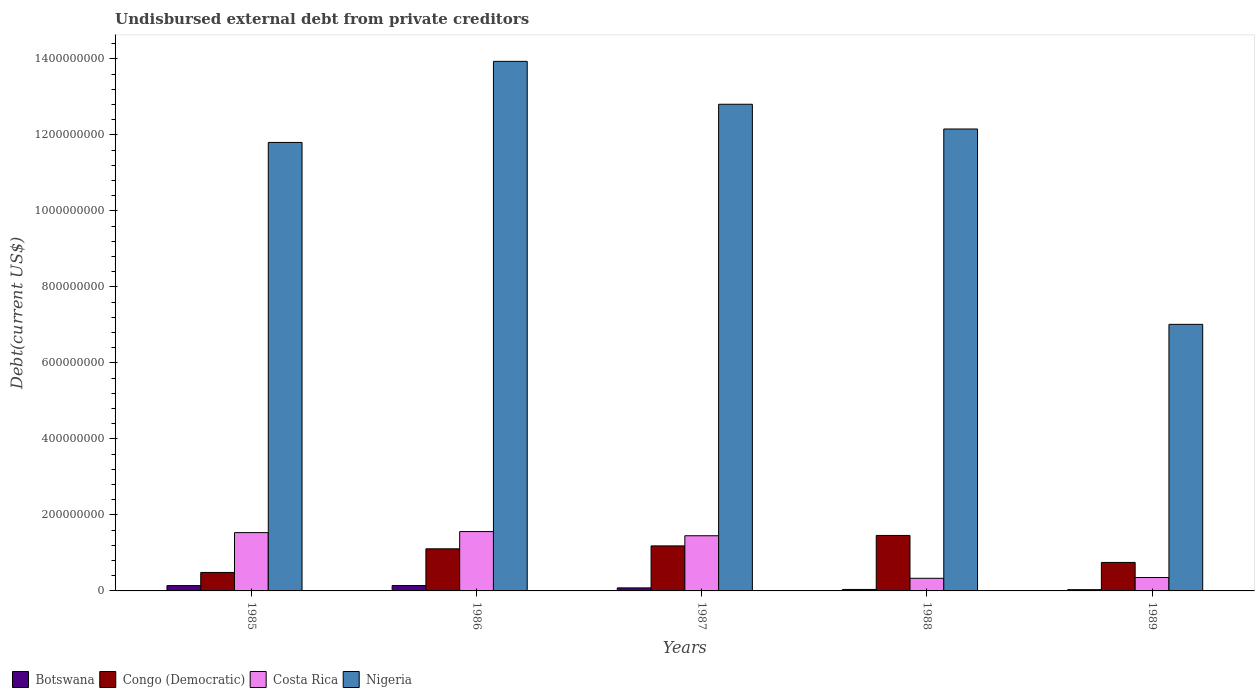How many bars are there on the 1st tick from the left?
Your answer should be very brief. 4. What is the total debt in Congo (Democratic) in 1988?
Provide a short and direct response. 1.46e+08. Across all years, what is the maximum total debt in Costa Rica?
Provide a short and direct response. 1.56e+08. Across all years, what is the minimum total debt in Nigeria?
Your answer should be compact. 7.01e+08. In which year was the total debt in Congo (Democratic) maximum?
Offer a very short reply. 1988. What is the total total debt in Costa Rica in the graph?
Ensure brevity in your answer.  5.23e+08. What is the difference between the total debt in Botswana in 1985 and that in 1987?
Make the answer very short. 6.06e+06. What is the difference between the total debt in Costa Rica in 1988 and the total debt in Botswana in 1986?
Offer a terse response. 1.90e+07. What is the average total debt in Botswana per year?
Offer a very short reply. 8.68e+06. In the year 1985, what is the difference between the total debt in Nigeria and total debt in Costa Rica?
Provide a short and direct response. 1.03e+09. In how many years, is the total debt in Congo (Democratic) greater than 800000000 US$?
Keep it short and to the point. 0. What is the ratio of the total debt in Botswana in 1985 to that in 1987?
Your answer should be compact. 1.76. Is the difference between the total debt in Nigeria in 1988 and 1989 greater than the difference between the total debt in Costa Rica in 1988 and 1989?
Provide a short and direct response. Yes. What is the difference between the highest and the second highest total debt in Costa Rica?
Ensure brevity in your answer.  2.75e+06. What is the difference between the highest and the lowest total debt in Botswana?
Provide a succinct answer. 1.09e+07. Is it the case that in every year, the sum of the total debt in Costa Rica and total debt in Congo (Democratic) is greater than the sum of total debt in Nigeria and total debt in Botswana?
Provide a succinct answer. Yes. What does the 2nd bar from the left in 1988 represents?
Provide a short and direct response. Congo (Democratic). What does the 4th bar from the right in 1986 represents?
Your answer should be compact. Botswana. Is it the case that in every year, the sum of the total debt in Botswana and total debt in Congo (Democratic) is greater than the total debt in Costa Rica?
Your answer should be compact. No. Are all the bars in the graph horizontal?
Your answer should be compact. No. How many years are there in the graph?
Provide a succinct answer. 5. What is the difference between two consecutive major ticks on the Y-axis?
Your response must be concise. 2.00e+08. Are the values on the major ticks of Y-axis written in scientific E-notation?
Keep it short and to the point. No. Where does the legend appear in the graph?
Your response must be concise. Bottom left. How many legend labels are there?
Your answer should be very brief. 4. How are the legend labels stacked?
Your answer should be compact. Horizontal. What is the title of the graph?
Provide a short and direct response. Undisbursed external debt from private creditors. Does "Congo (Democratic)" appear as one of the legend labels in the graph?
Provide a short and direct response. Yes. What is the label or title of the X-axis?
Give a very brief answer. Years. What is the label or title of the Y-axis?
Give a very brief answer. Debt(current US$). What is the Debt(current US$) in Botswana in 1985?
Ensure brevity in your answer.  1.41e+07. What is the Debt(current US$) in Congo (Democratic) in 1985?
Offer a terse response. 4.86e+07. What is the Debt(current US$) in Costa Rica in 1985?
Offer a terse response. 1.53e+08. What is the Debt(current US$) in Nigeria in 1985?
Offer a terse response. 1.18e+09. What is the Debt(current US$) in Botswana in 1986?
Offer a very short reply. 1.42e+07. What is the Debt(current US$) of Congo (Democratic) in 1986?
Your answer should be very brief. 1.11e+08. What is the Debt(current US$) in Costa Rica in 1986?
Ensure brevity in your answer.  1.56e+08. What is the Debt(current US$) of Nigeria in 1986?
Make the answer very short. 1.39e+09. What is the Debt(current US$) in Botswana in 1987?
Give a very brief answer. 7.99e+06. What is the Debt(current US$) in Congo (Democratic) in 1987?
Ensure brevity in your answer.  1.18e+08. What is the Debt(current US$) of Costa Rica in 1987?
Give a very brief answer. 1.45e+08. What is the Debt(current US$) in Nigeria in 1987?
Provide a short and direct response. 1.28e+09. What is the Debt(current US$) of Botswana in 1988?
Offer a terse response. 3.90e+06. What is the Debt(current US$) of Congo (Democratic) in 1988?
Provide a succinct answer. 1.46e+08. What is the Debt(current US$) in Costa Rica in 1988?
Provide a succinct answer. 3.32e+07. What is the Debt(current US$) of Nigeria in 1988?
Ensure brevity in your answer.  1.22e+09. What is the Debt(current US$) of Botswana in 1989?
Keep it short and to the point. 3.28e+06. What is the Debt(current US$) of Congo (Democratic) in 1989?
Ensure brevity in your answer.  7.50e+07. What is the Debt(current US$) in Costa Rica in 1989?
Offer a very short reply. 3.53e+07. What is the Debt(current US$) in Nigeria in 1989?
Provide a succinct answer. 7.01e+08. Across all years, what is the maximum Debt(current US$) of Botswana?
Ensure brevity in your answer.  1.42e+07. Across all years, what is the maximum Debt(current US$) of Congo (Democratic)?
Offer a terse response. 1.46e+08. Across all years, what is the maximum Debt(current US$) of Costa Rica?
Offer a very short reply. 1.56e+08. Across all years, what is the maximum Debt(current US$) in Nigeria?
Keep it short and to the point. 1.39e+09. Across all years, what is the minimum Debt(current US$) in Botswana?
Your response must be concise. 3.28e+06. Across all years, what is the minimum Debt(current US$) of Congo (Democratic)?
Provide a short and direct response. 4.86e+07. Across all years, what is the minimum Debt(current US$) in Costa Rica?
Make the answer very short. 3.32e+07. Across all years, what is the minimum Debt(current US$) in Nigeria?
Keep it short and to the point. 7.01e+08. What is the total Debt(current US$) of Botswana in the graph?
Provide a succinct answer. 4.34e+07. What is the total Debt(current US$) in Congo (Democratic) in the graph?
Ensure brevity in your answer.  4.99e+08. What is the total Debt(current US$) in Costa Rica in the graph?
Make the answer very short. 5.23e+08. What is the total Debt(current US$) of Nigeria in the graph?
Your answer should be compact. 5.77e+09. What is the difference between the Debt(current US$) of Botswana in 1985 and that in 1986?
Give a very brief answer. -1.43e+05. What is the difference between the Debt(current US$) in Congo (Democratic) in 1985 and that in 1986?
Make the answer very short. -6.22e+07. What is the difference between the Debt(current US$) of Costa Rica in 1985 and that in 1986?
Provide a short and direct response. -2.75e+06. What is the difference between the Debt(current US$) of Nigeria in 1985 and that in 1986?
Provide a short and direct response. -2.13e+08. What is the difference between the Debt(current US$) of Botswana in 1985 and that in 1987?
Your answer should be very brief. 6.06e+06. What is the difference between the Debt(current US$) in Congo (Democratic) in 1985 and that in 1987?
Give a very brief answer. -6.99e+07. What is the difference between the Debt(current US$) of Costa Rica in 1985 and that in 1987?
Provide a succinct answer. 8.21e+06. What is the difference between the Debt(current US$) of Nigeria in 1985 and that in 1987?
Offer a very short reply. -1.00e+08. What is the difference between the Debt(current US$) of Botswana in 1985 and that in 1988?
Provide a succinct answer. 1.02e+07. What is the difference between the Debt(current US$) in Congo (Democratic) in 1985 and that in 1988?
Your response must be concise. -9.73e+07. What is the difference between the Debt(current US$) in Costa Rica in 1985 and that in 1988?
Offer a very short reply. 1.20e+08. What is the difference between the Debt(current US$) of Nigeria in 1985 and that in 1988?
Ensure brevity in your answer.  -3.53e+07. What is the difference between the Debt(current US$) in Botswana in 1985 and that in 1989?
Give a very brief answer. 1.08e+07. What is the difference between the Debt(current US$) in Congo (Democratic) in 1985 and that in 1989?
Provide a succinct answer. -2.64e+07. What is the difference between the Debt(current US$) in Costa Rica in 1985 and that in 1989?
Keep it short and to the point. 1.18e+08. What is the difference between the Debt(current US$) in Nigeria in 1985 and that in 1989?
Give a very brief answer. 4.79e+08. What is the difference between the Debt(current US$) of Botswana in 1986 and that in 1987?
Your response must be concise. 6.21e+06. What is the difference between the Debt(current US$) in Congo (Democratic) in 1986 and that in 1987?
Make the answer very short. -7.70e+06. What is the difference between the Debt(current US$) of Costa Rica in 1986 and that in 1987?
Your answer should be very brief. 1.10e+07. What is the difference between the Debt(current US$) in Nigeria in 1986 and that in 1987?
Keep it short and to the point. 1.13e+08. What is the difference between the Debt(current US$) of Botswana in 1986 and that in 1988?
Provide a succinct answer. 1.03e+07. What is the difference between the Debt(current US$) in Congo (Democratic) in 1986 and that in 1988?
Make the answer very short. -3.52e+07. What is the difference between the Debt(current US$) in Costa Rica in 1986 and that in 1988?
Offer a very short reply. 1.23e+08. What is the difference between the Debt(current US$) of Nigeria in 1986 and that in 1988?
Your answer should be very brief. 1.78e+08. What is the difference between the Debt(current US$) of Botswana in 1986 and that in 1989?
Provide a short and direct response. 1.09e+07. What is the difference between the Debt(current US$) of Congo (Democratic) in 1986 and that in 1989?
Offer a terse response. 3.58e+07. What is the difference between the Debt(current US$) of Costa Rica in 1986 and that in 1989?
Your response must be concise. 1.21e+08. What is the difference between the Debt(current US$) of Nigeria in 1986 and that in 1989?
Ensure brevity in your answer.  6.92e+08. What is the difference between the Debt(current US$) of Botswana in 1987 and that in 1988?
Provide a short and direct response. 4.09e+06. What is the difference between the Debt(current US$) of Congo (Democratic) in 1987 and that in 1988?
Offer a very short reply. -2.75e+07. What is the difference between the Debt(current US$) in Costa Rica in 1987 and that in 1988?
Offer a very short reply. 1.12e+08. What is the difference between the Debt(current US$) of Nigeria in 1987 and that in 1988?
Your answer should be very brief. 6.51e+07. What is the difference between the Debt(current US$) in Botswana in 1987 and that in 1989?
Make the answer very short. 4.70e+06. What is the difference between the Debt(current US$) of Congo (Democratic) in 1987 and that in 1989?
Offer a very short reply. 4.35e+07. What is the difference between the Debt(current US$) of Costa Rica in 1987 and that in 1989?
Offer a very short reply. 1.10e+08. What is the difference between the Debt(current US$) in Nigeria in 1987 and that in 1989?
Ensure brevity in your answer.  5.79e+08. What is the difference between the Debt(current US$) in Botswana in 1988 and that in 1989?
Offer a very short reply. 6.15e+05. What is the difference between the Debt(current US$) in Congo (Democratic) in 1988 and that in 1989?
Offer a terse response. 7.10e+07. What is the difference between the Debt(current US$) of Costa Rica in 1988 and that in 1989?
Your response must be concise. -2.06e+06. What is the difference between the Debt(current US$) in Nigeria in 1988 and that in 1989?
Your answer should be compact. 5.14e+08. What is the difference between the Debt(current US$) of Botswana in 1985 and the Debt(current US$) of Congo (Democratic) in 1986?
Your answer should be very brief. -9.67e+07. What is the difference between the Debt(current US$) in Botswana in 1985 and the Debt(current US$) in Costa Rica in 1986?
Provide a succinct answer. -1.42e+08. What is the difference between the Debt(current US$) in Botswana in 1985 and the Debt(current US$) in Nigeria in 1986?
Your answer should be compact. -1.38e+09. What is the difference between the Debt(current US$) of Congo (Democratic) in 1985 and the Debt(current US$) of Costa Rica in 1986?
Your answer should be compact. -1.08e+08. What is the difference between the Debt(current US$) of Congo (Democratic) in 1985 and the Debt(current US$) of Nigeria in 1986?
Offer a terse response. -1.34e+09. What is the difference between the Debt(current US$) of Costa Rica in 1985 and the Debt(current US$) of Nigeria in 1986?
Your response must be concise. -1.24e+09. What is the difference between the Debt(current US$) in Botswana in 1985 and the Debt(current US$) in Congo (Democratic) in 1987?
Provide a succinct answer. -1.04e+08. What is the difference between the Debt(current US$) of Botswana in 1985 and the Debt(current US$) of Costa Rica in 1987?
Offer a terse response. -1.31e+08. What is the difference between the Debt(current US$) in Botswana in 1985 and the Debt(current US$) in Nigeria in 1987?
Your answer should be compact. -1.27e+09. What is the difference between the Debt(current US$) of Congo (Democratic) in 1985 and the Debt(current US$) of Costa Rica in 1987?
Keep it short and to the point. -9.66e+07. What is the difference between the Debt(current US$) in Congo (Democratic) in 1985 and the Debt(current US$) in Nigeria in 1987?
Ensure brevity in your answer.  -1.23e+09. What is the difference between the Debt(current US$) of Costa Rica in 1985 and the Debt(current US$) of Nigeria in 1987?
Offer a terse response. -1.13e+09. What is the difference between the Debt(current US$) in Botswana in 1985 and the Debt(current US$) in Congo (Democratic) in 1988?
Your response must be concise. -1.32e+08. What is the difference between the Debt(current US$) of Botswana in 1985 and the Debt(current US$) of Costa Rica in 1988?
Your response must be concise. -1.92e+07. What is the difference between the Debt(current US$) of Botswana in 1985 and the Debt(current US$) of Nigeria in 1988?
Give a very brief answer. -1.20e+09. What is the difference between the Debt(current US$) in Congo (Democratic) in 1985 and the Debt(current US$) in Costa Rica in 1988?
Offer a very short reply. 1.54e+07. What is the difference between the Debt(current US$) in Congo (Democratic) in 1985 and the Debt(current US$) in Nigeria in 1988?
Ensure brevity in your answer.  -1.17e+09. What is the difference between the Debt(current US$) of Costa Rica in 1985 and the Debt(current US$) of Nigeria in 1988?
Provide a succinct answer. -1.06e+09. What is the difference between the Debt(current US$) in Botswana in 1985 and the Debt(current US$) in Congo (Democratic) in 1989?
Offer a terse response. -6.09e+07. What is the difference between the Debt(current US$) of Botswana in 1985 and the Debt(current US$) of Costa Rica in 1989?
Provide a short and direct response. -2.12e+07. What is the difference between the Debt(current US$) of Botswana in 1985 and the Debt(current US$) of Nigeria in 1989?
Give a very brief answer. -6.87e+08. What is the difference between the Debt(current US$) of Congo (Democratic) in 1985 and the Debt(current US$) of Costa Rica in 1989?
Give a very brief answer. 1.33e+07. What is the difference between the Debt(current US$) in Congo (Democratic) in 1985 and the Debt(current US$) in Nigeria in 1989?
Provide a short and direct response. -6.53e+08. What is the difference between the Debt(current US$) in Costa Rica in 1985 and the Debt(current US$) in Nigeria in 1989?
Give a very brief answer. -5.48e+08. What is the difference between the Debt(current US$) in Botswana in 1986 and the Debt(current US$) in Congo (Democratic) in 1987?
Your response must be concise. -1.04e+08. What is the difference between the Debt(current US$) of Botswana in 1986 and the Debt(current US$) of Costa Rica in 1987?
Ensure brevity in your answer.  -1.31e+08. What is the difference between the Debt(current US$) of Botswana in 1986 and the Debt(current US$) of Nigeria in 1987?
Make the answer very short. -1.27e+09. What is the difference between the Debt(current US$) of Congo (Democratic) in 1986 and the Debt(current US$) of Costa Rica in 1987?
Offer a terse response. -3.44e+07. What is the difference between the Debt(current US$) of Congo (Democratic) in 1986 and the Debt(current US$) of Nigeria in 1987?
Make the answer very short. -1.17e+09. What is the difference between the Debt(current US$) in Costa Rica in 1986 and the Debt(current US$) in Nigeria in 1987?
Offer a terse response. -1.12e+09. What is the difference between the Debt(current US$) in Botswana in 1986 and the Debt(current US$) in Congo (Democratic) in 1988?
Provide a succinct answer. -1.32e+08. What is the difference between the Debt(current US$) in Botswana in 1986 and the Debt(current US$) in Costa Rica in 1988?
Ensure brevity in your answer.  -1.90e+07. What is the difference between the Debt(current US$) of Botswana in 1986 and the Debt(current US$) of Nigeria in 1988?
Offer a very short reply. -1.20e+09. What is the difference between the Debt(current US$) of Congo (Democratic) in 1986 and the Debt(current US$) of Costa Rica in 1988?
Your answer should be compact. 7.76e+07. What is the difference between the Debt(current US$) in Congo (Democratic) in 1986 and the Debt(current US$) in Nigeria in 1988?
Keep it short and to the point. -1.10e+09. What is the difference between the Debt(current US$) in Costa Rica in 1986 and the Debt(current US$) in Nigeria in 1988?
Your response must be concise. -1.06e+09. What is the difference between the Debt(current US$) in Botswana in 1986 and the Debt(current US$) in Congo (Democratic) in 1989?
Offer a very short reply. -6.08e+07. What is the difference between the Debt(current US$) of Botswana in 1986 and the Debt(current US$) of Costa Rica in 1989?
Your answer should be compact. -2.11e+07. What is the difference between the Debt(current US$) of Botswana in 1986 and the Debt(current US$) of Nigeria in 1989?
Your answer should be very brief. -6.87e+08. What is the difference between the Debt(current US$) in Congo (Democratic) in 1986 and the Debt(current US$) in Costa Rica in 1989?
Provide a short and direct response. 7.55e+07. What is the difference between the Debt(current US$) of Congo (Democratic) in 1986 and the Debt(current US$) of Nigeria in 1989?
Your response must be concise. -5.91e+08. What is the difference between the Debt(current US$) in Costa Rica in 1986 and the Debt(current US$) in Nigeria in 1989?
Your response must be concise. -5.45e+08. What is the difference between the Debt(current US$) of Botswana in 1987 and the Debt(current US$) of Congo (Democratic) in 1988?
Offer a terse response. -1.38e+08. What is the difference between the Debt(current US$) in Botswana in 1987 and the Debt(current US$) in Costa Rica in 1988?
Provide a succinct answer. -2.52e+07. What is the difference between the Debt(current US$) of Botswana in 1987 and the Debt(current US$) of Nigeria in 1988?
Give a very brief answer. -1.21e+09. What is the difference between the Debt(current US$) of Congo (Democratic) in 1987 and the Debt(current US$) of Costa Rica in 1988?
Provide a short and direct response. 8.53e+07. What is the difference between the Debt(current US$) of Congo (Democratic) in 1987 and the Debt(current US$) of Nigeria in 1988?
Provide a short and direct response. -1.10e+09. What is the difference between the Debt(current US$) in Costa Rica in 1987 and the Debt(current US$) in Nigeria in 1988?
Give a very brief answer. -1.07e+09. What is the difference between the Debt(current US$) in Botswana in 1987 and the Debt(current US$) in Congo (Democratic) in 1989?
Ensure brevity in your answer.  -6.70e+07. What is the difference between the Debt(current US$) of Botswana in 1987 and the Debt(current US$) of Costa Rica in 1989?
Offer a very short reply. -2.73e+07. What is the difference between the Debt(current US$) in Botswana in 1987 and the Debt(current US$) in Nigeria in 1989?
Your response must be concise. -6.93e+08. What is the difference between the Debt(current US$) in Congo (Democratic) in 1987 and the Debt(current US$) in Costa Rica in 1989?
Offer a terse response. 8.32e+07. What is the difference between the Debt(current US$) of Congo (Democratic) in 1987 and the Debt(current US$) of Nigeria in 1989?
Offer a terse response. -5.83e+08. What is the difference between the Debt(current US$) in Costa Rica in 1987 and the Debt(current US$) in Nigeria in 1989?
Give a very brief answer. -5.56e+08. What is the difference between the Debt(current US$) in Botswana in 1988 and the Debt(current US$) in Congo (Democratic) in 1989?
Provide a succinct answer. -7.11e+07. What is the difference between the Debt(current US$) of Botswana in 1988 and the Debt(current US$) of Costa Rica in 1989?
Your response must be concise. -3.14e+07. What is the difference between the Debt(current US$) of Botswana in 1988 and the Debt(current US$) of Nigeria in 1989?
Make the answer very short. -6.97e+08. What is the difference between the Debt(current US$) in Congo (Democratic) in 1988 and the Debt(current US$) in Costa Rica in 1989?
Make the answer very short. 1.11e+08. What is the difference between the Debt(current US$) of Congo (Democratic) in 1988 and the Debt(current US$) of Nigeria in 1989?
Your answer should be very brief. -5.55e+08. What is the difference between the Debt(current US$) in Costa Rica in 1988 and the Debt(current US$) in Nigeria in 1989?
Provide a short and direct response. -6.68e+08. What is the average Debt(current US$) of Botswana per year?
Ensure brevity in your answer.  8.68e+06. What is the average Debt(current US$) of Congo (Democratic) per year?
Ensure brevity in your answer.  9.98e+07. What is the average Debt(current US$) of Costa Rica per year?
Your response must be concise. 1.05e+08. What is the average Debt(current US$) of Nigeria per year?
Your answer should be compact. 1.15e+09. In the year 1985, what is the difference between the Debt(current US$) of Botswana and Debt(current US$) of Congo (Democratic)?
Your response must be concise. -3.46e+07. In the year 1985, what is the difference between the Debt(current US$) in Botswana and Debt(current US$) in Costa Rica?
Your response must be concise. -1.39e+08. In the year 1985, what is the difference between the Debt(current US$) in Botswana and Debt(current US$) in Nigeria?
Offer a very short reply. -1.17e+09. In the year 1985, what is the difference between the Debt(current US$) of Congo (Democratic) and Debt(current US$) of Costa Rica?
Your answer should be compact. -1.05e+08. In the year 1985, what is the difference between the Debt(current US$) in Congo (Democratic) and Debt(current US$) in Nigeria?
Provide a short and direct response. -1.13e+09. In the year 1985, what is the difference between the Debt(current US$) in Costa Rica and Debt(current US$) in Nigeria?
Provide a short and direct response. -1.03e+09. In the year 1986, what is the difference between the Debt(current US$) of Botswana and Debt(current US$) of Congo (Democratic)?
Give a very brief answer. -9.66e+07. In the year 1986, what is the difference between the Debt(current US$) of Botswana and Debt(current US$) of Costa Rica?
Keep it short and to the point. -1.42e+08. In the year 1986, what is the difference between the Debt(current US$) of Botswana and Debt(current US$) of Nigeria?
Offer a very short reply. -1.38e+09. In the year 1986, what is the difference between the Debt(current US$) in Congo (Democratic) and Debt(current US$) in Costa Rica?
Provide a short and direct response. -4.54e+07. In the year 1986, what is the difference between the Debt(current US$) in Congo (Democratic) and Debt(current US$) in Nigeria?
Your response must be concise. -1.28e+09. In the year 1986, what is the difference between the Debt(current US$) in Costa Rica and Debt(current US$) in Nigeria?
Give a very brief answer. -1.24e+09. In the year 1987, what is the difference between the Debt(current US$) in Botswana and Debt(current US$) in Congo (Democratic)?
Ensure brevity in your answer.  -1.10e+08. In the year 1987, what is the difference between the Debt(current US$) in Botswana and Debt(current US$) in Costa Rica?
Give a very brief answer. -1.37e+08. In the year 1987, what is the difference between the Debt(current US$) of Botswana and Debt(current US$) of Nigeria?
Your response must be concise. -1.27e+09. In the year 1987, what is the difference between the Debt(current US$) in Congo (Democratic) and Debt(current US$) in Costa Rica?
Offer a terse response. -2.67e+07. In the year 1987, what is the difference between the Debt(current US$) of Congo (Democratic) and Debt(current US$) of Nigeria?
Ensure brevity in your answer.  -1.16e+09. In the year 1987, what is the difference between the Debt(current US$) of Costa Rica and Debt(current US$) of Nigeria?
Your answer should be compact. -1.14e+09. In the year 1988, what is the difference between the Debt(current US$) of Botswana and Debt(current US$) of Congo (Democratic)?
Your answer should be very brief. -1.42e+08. In the year 1988, what is the difference between the Debt(current US$) in Botswana and Debt(current US$) in Costa Rica?
Keep it short and to the point. -2.93e+07. In the year 1988, what is the difference between the Debt(current US$) of Botswana and Debt(current US$) of Nigeria?
Provide a succinct answer. -1.21e+09. In the year 1988, what is the difference between the Debt(current US$) in Congo (Democratic) and Debt(current US$) in Costa Rica?
Your answer should be compact. 1.13e+08. In the year 1988, what is the difference between the Debt(current US$) in Congo (Democratic) and Debt(current US$) in Nigeria?
Your response must be concise. -1.07e+09. In the year 1988, what is the difference between the Debt(current US$) of Costa Rica and Debt(current US$) of Nigeria?
Your answer should be very brief. -1.18e+09. In the year 1989, what is the difference between the Debt(current US$) of Botswana and Debt(current US$) of Congo (Democratic)?
Make the answer very short. -7.17e+07. In the year 1989, what is the difference between the Debt(current US$) of Botswana and Debt(current US$) of Costa Rica?
Offer a very short reply. -3.20e+07. In the year 1989, what is the difference between the Debt(current US$) of Botswana and Debt(current US$) of Nigeria?
Your response must be concise. -6.98e+08. In the year 1989, what is the difference between the Debt(current US$) in Congo (Democratic) and Debt(current US$) in Costa Rica?
Keep it short and to the point. 3.97e+07. In the year 1989, what is the difference between the Debt(current US$) in Congo (Democratic) and Debt(current US$) in Nigeria?
Keep it short and to the point. -6.26e+08. In the year 1989, what is the difference between the Debt(current US$) in Costa Rica and Debt(current US$) in Nigeria?
Ensure brevity in your answer.  -6.66e+08. What is the ratio of the Debt(current US$) in Botswana in 1985 to that in 1986?
Your answer should be compact. 0.99. What is the ratio of the Debt(current US$) of Congo (Democratic) in 1985 to that in 1986?
Your answer should be compact. 0.44. What is the ratio of the Debt(current US$) in Costa Rica in 1985 to that in 1986?
Your answer should be compact. 0.98. What is the ratio of the Debt(current US$) in Nigeria in 1985 to that in 1986?
Keep it short and to the point. 0.85. What is the ratio of the Debt(current US$) in Botswana in 1985 to that in 1987?
Keep it short and to the point. 1.76. What is the ratio of the Debt(current US$) of Congo (Democratic) in 1985 to that in 1987?
Your answer should be very brief. 0.41. What is the ratio of the Debt(current US$) in Costa Rica in 1985 to that in 1987?
Provide a short and direct response. 1.06. What is the ratio of the Debt(current US$) in Nigeria in 1985 to that in 1987?
Keep it short and to the point. 0.92. What is the ratio of the Debt(current US$) in Botswana in 1985 to that in 1988?
Your answer should be compact. 3.6. What is the ratio of the Debt(current US$) of Congo (Democratic) in 1985 to that in 1988?
Keep it short and to the point. 0.33. What is the ratio of the Debt(current US$) in Costa Rica in 1985 to that in 1988?
Give a very brief answer. 4.62. What is the ratio of the Debt(current US$) in Nigeria in 1985 to that in 1988?
Make the answer very short. 0.97. What is the ratio of the Debt(current US$) in Botswana in 1985 to that in 1989?
Offer a very short reply. 4.28. What is the ratio of the Debt(current US$) in Congo (Democratic) in 1985 to that in 1989?
Make the answer very short. 0.65. What is the ratio of the Debt(current US$) in Costa Rica in 1985 to that in 1989?
Provide a succinct answer. 4.35. What is the ratio of the Debt(current US$) in Nigeria in 1985 to that in 1989?
Your answer should be very brief. 1.68. What is the ratio of the Debt(current US$) in Botswana in 1986 to that in 1987?
Ensure brevity in your answer.  1.78. What is the ratio of the Debt(current US$) in Congo (Democratic) in 1986 to that in 1987?
Your answer should be compact. 0.94. What is the ratio of the Debt(current US$) of Costa Rica in 1986 to that in 1987?
Provide a short and direct response. 1.08. What is the ratio of the Debt(current US$) in Nigeria in 1986 to that in 1987?
Offer a very short reply. 1.09. What is the ratio of the Debt(current US$) in Botswana in 1986 to that in 1988?
Make the answer very short. 3.64. What is the ratio of the Debt(current US$) of Congo (Democratic) in 1986 to that in 1988?
Ensure brevity in your answer.  0.76. What is the ratio of the Debt(current US$) of Costa Rica in 1986 to that in 1988?
Ensure brevity in your answer.  4.7. What is the ratio of the Debt(current US$) in Nigeria in 1986 to that in 1988?
Keep it short and to the point. 1.15. What is the ratio of the Debt(current US$) in Botswana in 1986 to that in 1989?
Your answer should be compact. 4.32. What is the ratio of the Debt(current US$) in Congo (Democratic) in 1986 to that in 1989?
Provide a succinct answer. 1.48. What is the ratio of the Debt(current US$) of Costa Rica in 1986 to that in 1989?
Your answer should be compact. 4.42. What is the ratio of the Debt(current US$) in Nigeria in 1986 to that in 1989?
Keep it short and to the point. 1.99. What is the ratio of the Debt(current US$) in Botswana in 1987 to that in 1988?
Ensure brevity in your answer.  2.05. What is the ratio of the Debt(current US$) of Congo (Democratic) in 1987 to that in 1988?
Keep it short and to the point. 0.81. What is the ratio of the Debt(current US$) of Costa Rica in 1987 to that in 1988?
Your response must be concise. 4.37. What is the ratio of the Debt(current US$) of Nigeria in 1987 to that in 1988?
Offer a very short reply. 1.05. What is the ratio of the Debt(current US$) of Botswana in 1987 to that in 1989?
Make the answer very short. 2.43. What is the ratio of the Debt(current US$) of Congo (Democratic) in 1987 to that in 1989?
Give a very brief answer. 1.58. What is the ratio of the Debt(current US$) of Costa Rica in 1987 to that in 1989?
Your response must be concise. 4.11. What is the ratio of the Debt(current US$) of Nigeria in 1987 to that in 1989?
Provide a succinct answer. 1.83. What is the ratio of the Debt(current US$) in Botswana in 1988 to that in 1989?
Ensure brevity in your answer.  1.19. What is the ratio of the Debt(current US$) of Congo (Democratic) in 1988 to that in 1989?
Provide a short and direct response. 1.95. What is the ratio of the Debt(current US$) of Costa Rica in 1988 to that in 1989?
Your answer should be compact. 0.94. What is the ratio of the Debt(current US$) of Nigeria in 1988 to that in 1989?
Your answer should be compact. 1.73. What is the difference between the highest and the second highest Debt(current US$) in Botswana?
Your response must be concise. 1.43e+05. What is the difference between the highest and the second highest Debt(current US$) of Congo (Democratic)?
Your answer should be very brief. 2.75e+07. What is the difference between the highest and the second highest Debt(current US$) of Costa Rica?
Your answer should be compact. 2.75e+06. What is the difference between the highest and the second highest Debt(current US$) of Nigeria?
Give a very brief answer. 1.13e+08. What is the difference between the highest and the lowest Debt(current US$) of Botswana?
Your answer should be very brief. 1.09e+07. What is the difference between the highest and the lowest Debt(current US$) of Congo (Democratic)?
Keep it short and to the point. 9.73e+07. What is the difference between the highest and the lowest Debt(current US$) of Costa Rica?
Offer a very short reply. 1.23e+08. What is the difference between the highest and the lowest Debt(current US$) in Nigeria?
Ensure brevity in your answer.  6.92e+08. 